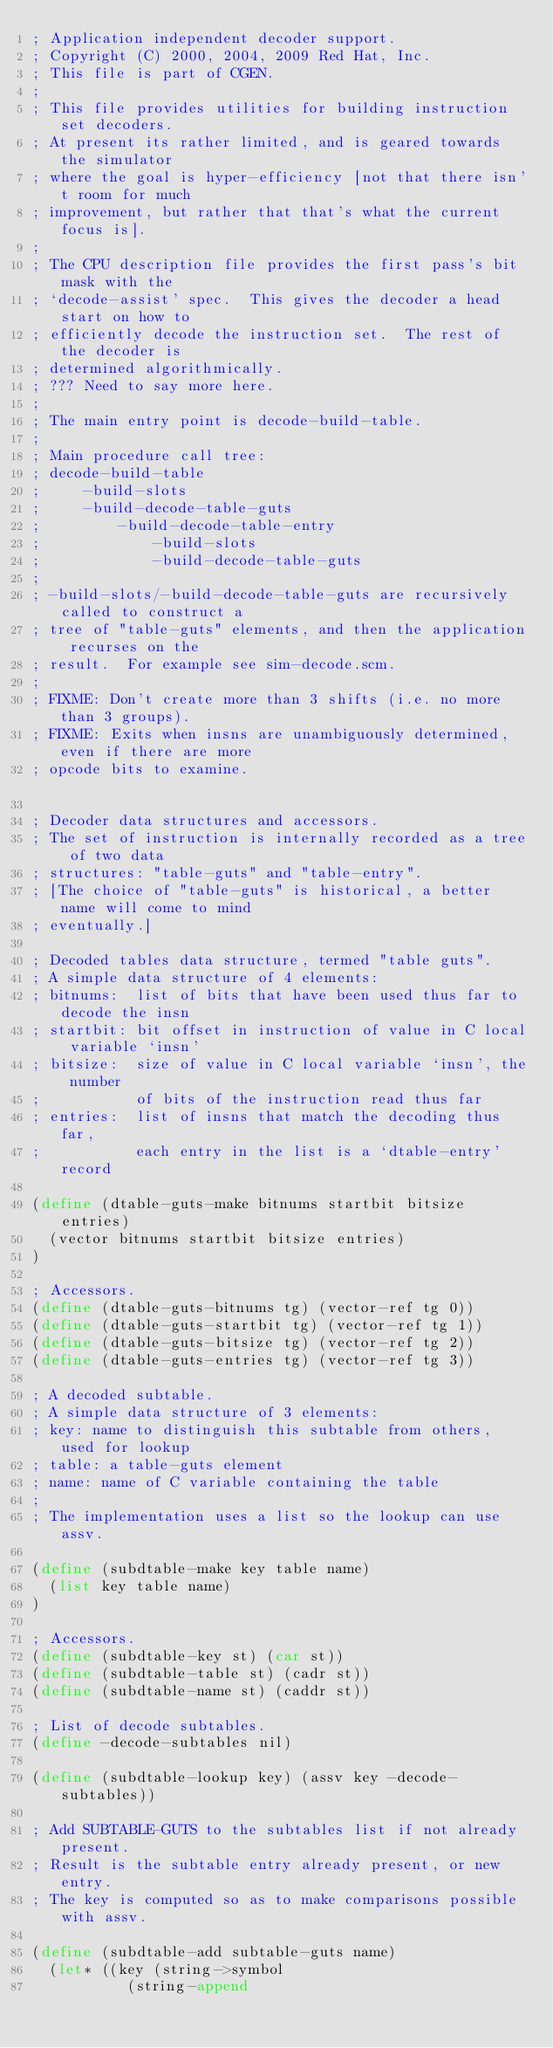Convert code to text. <code><loc_0><loc_0><loc_500><loc_500><_Scheme_>; Application independent decoder support.
; Copyright (C) 2000, 2004, 2009 Red Hat, Inc.
; This file is part of CGEN.
;
; This file provides utilities for building instruction set decoders.
; At present its rather limited, and is geared towards the simulator
; where the goal is hyper-efficiency [not that there isn't room for much
; improvement, but rather that that's what the current focus is].
;
; The CPU description file provides the first pass's bit mask with the
; `decode-assist' spec.  This gives the decoder a head start on how to
; efficiently decode the instruction set.  The rest of the decoder is
; determined algorithmically.
; ??? Need to say more here.
;
; The main entry point is decode-build-table.
;
; Main procedure call tree:
; decode-build-table
;     -build-slots
;     -build-decode-table-guts
;         -build-decode-table-entry
;             -build-slots
;             -build-decode-table-guts
;
; -build-slots/-build-decode-table-guts are recursively called to construct a
; tree of "table-guts" elements, and then the application recurses on the
; result.  For example see sim-decode.scm.
;
; FIXME: Don't create more than 3 shifts (i.e. no more than 3 groups).
; FIXME: Exits when insns are unambiguously determined, even if there are more
; opcode bits to examine.

; Decoder data structures and accessors.
; The set of instruction is internally recorded as a tree of two data
; structures: "table-guts" and "table-entry".
; [The choice of "table-guts" is historical, a better name will come to mind
; eventually.]

; Decoded tables data structure, termed "table guts".
; A simple data structure of 4 elements:
; bitnums:  list of bits that have been used thus far to decode the insn
; startbit: bit offset in instruction of value in C local variable `insn'
; bitsize:  size of value in C local variable `insn', the number
;           of bits of the instruction read thus far
; entries:  list of insns that match the decoding thus far,
;           each entry in the list is a `dtable-entry' record

(define (dtable-guts-make bitnums startbit bitsize entries)
  (vector bitnums startbit bitsize entries)
)

; Accessors.
(define (dtable-guts-bitnums tg) (vector-ref tg 0))
(define (dtable-guts-startbit tg) (vector-ref tg 1))
(define (dtable-guts-bitsize tg) (vector-ref tg 2))
(define (dtable-guts-entries tg) (vector-ref tg 3))

; A decoded subtable.
; A simple data structure of 3 elements:
; key: name to distinguish this subtable from others, used for lookup
; table: a table-guts element
; name: name of C variable containing the table
;
; The implementation uses a list so the lookup can use assv.

(define (subdtable-make key table name)
  (list key table name)
)

; Accessors.
(define (subdtable-key st) (car st))
(define (subdtable-table st) (cadr st))
(define (subdtable-name st) (caddr st))

; List of decode subtables.
(define -decode-subtables nil)

(define (subdtable-lookup key) (assv key -decode-subtables))

; Add SUBTABLE-GUTS to the subtables list if not already present.
; Result is the subtable entry already present, or new entry.
; The key is computed so as to make comparisons possible with assv.

(define (subdtable-add subtable-guts name)
  (let* ((key (string->symbol
	       (string-append</code> 